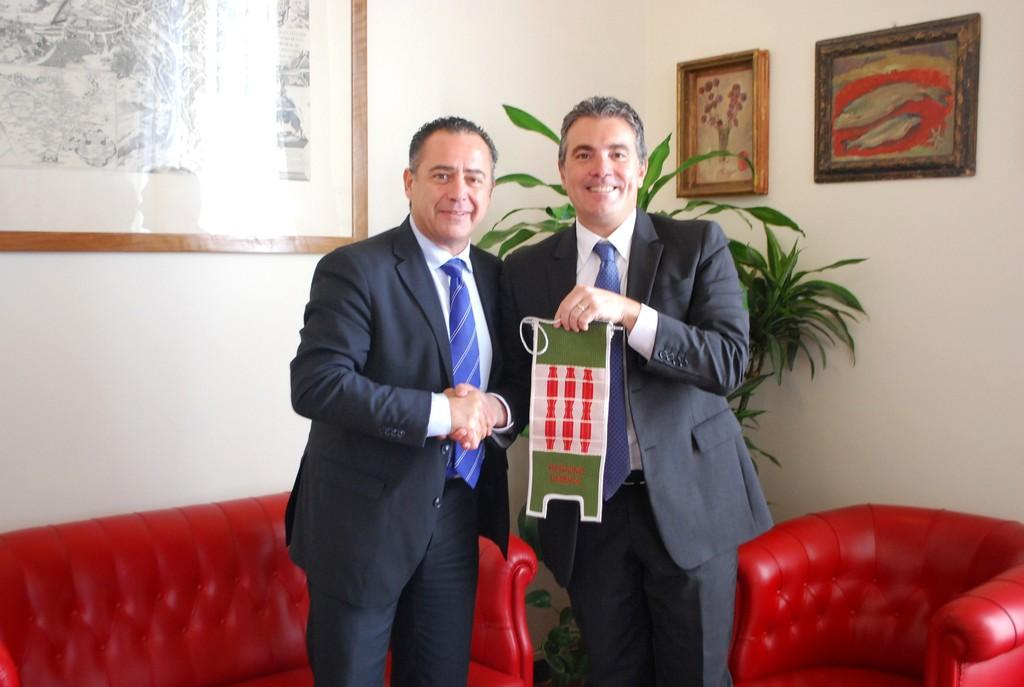How many people are in the image? There are two men in the image. What are the men doing in the image? The men are standing and holding a paper. What can be seen in the background of the image? There is a wall in the background of the image. Is there any decoration or object on the wall? Yes, there is a photo frame on the wall. What type of flame can be seen coming from the men's hands in the image? There is no flame present in the image; the men are holding a paper. In which room of the house is the image taken? The image does not provide enough information to determine the specific room in which it was taken. 